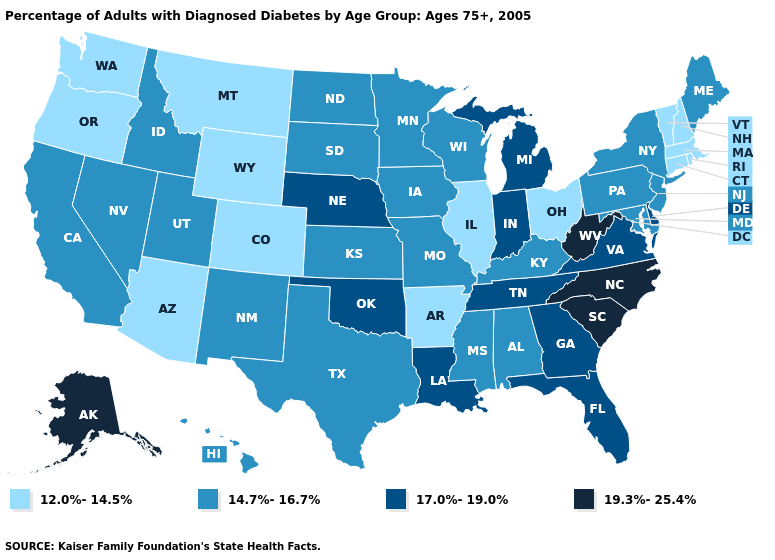Name the states that have a value in the range 17.0%-19.0%?
Keep it brief. Delaware, Florida, Georgia, Indiana, Louisiana, Michigan, Nebraska, Oklahoma, Tennessee, Virginia. What is the lowest value in the Northeast?
Keep it brief. 12.0%-14.5%. What is the value of Delaware?
Short answer required. 17.0%-19.0%. Name the states that have a value in the range 19.3%-25.4%?
Concise answer only. Alaska, North Carolina, South Carolina, West Virginia. What is the lowest value in states that border Wisconsin?
Answer briefly. 12.0%-14.5%. What is the value of North Dakota?
Answer briefly. 14.7%-16.7%. Which states hav the highest value in the South?
Give a very brief answer. North Carolina, South Carolina, West Virginia. Among the states that border California , which have the lowest value?
Keep it brief. Arizona, Oregon. Name the states that have a value in the range 12.0%-14.5%?
Write a very short answer. Arizona, Arkansas, Colorado, Connecticut, Illinois, Massachusetts, Montana, New Hampshire, Ohio, Oregon, Rhode Island, Vermont, Washington, Wyoming. Which states have the lowest value in the Northeast?
Concise answer only. Connecticut, Massachusetts, New Hampshire, Rhode Island, Vermont. Among the states that border North Carolina , does Virginia have the highest value?
Be succinct. No. Among the states that border Louisiana , which have the highest value?
Keep it brief. Mississippi, Texas. Which states hav the highest value in the MidWest?
Short answer required. Indiana, Michigan, Nebraska. Does Arkansas have the lowest value in the USA?
Answer briefly. Yes. Among the states that border Connecticut , does Massachusetts have the lowest value?
Answer briefly. Yes. 